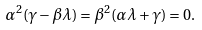Convert formula to latex. <formula><loc_0><loc_0><loc_500><loc_500>\alpha ^ { 2 } ( \gamma - \beta \lambda ) = \beta ^ { 2 } ( \alpha \lambda + \gamma ) = 0 .</formula> 